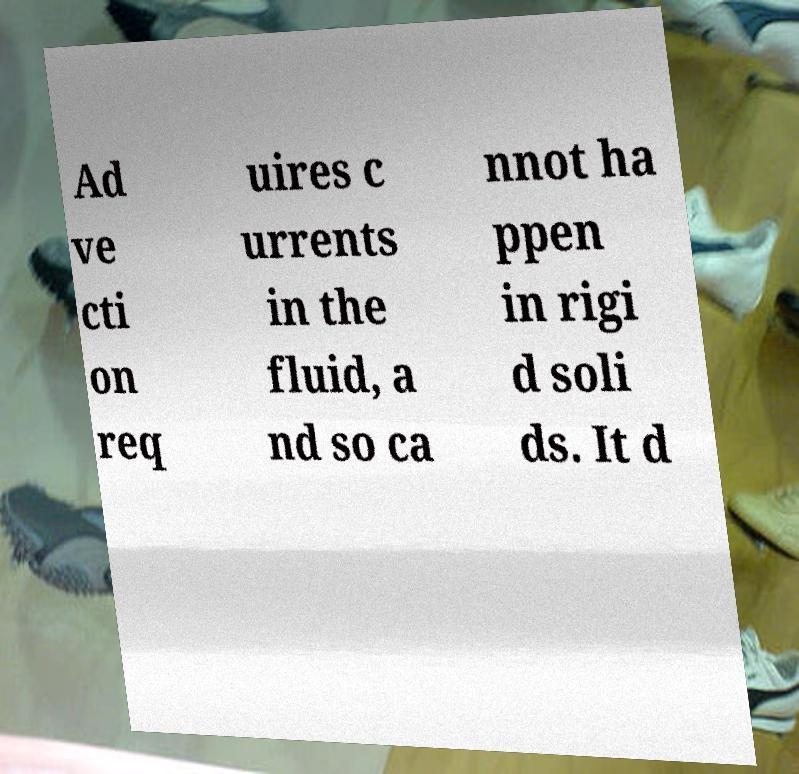For documentation purposes, I need the text within this image transcribed. Could you provide that? Ad ve cti on req uires c urrents in the fluid, a nd so ca nnot ha ppen in rigi d soli ds. It d 